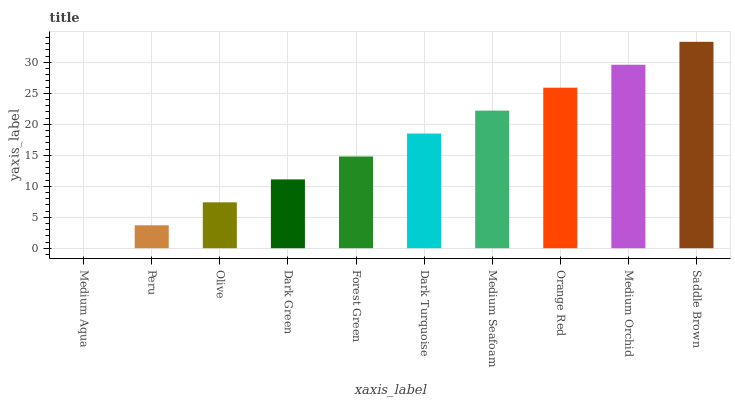Is Medium Aqua the minimum?
Answer yes or no. Yes. Is Saddle Brown the maximum?
Answer yes or no. Yes. Is Peru the minimum?
Answer yes or no. No. Is Peru the maximum?
Answer yes or no. No. Is Peru greater than Medium Aqua?
Answer yes or no. Yes. Is Medium Aqua less than Peru?
Answer yes or no. Yes. Is Medium Aqua greater than Peru?
Answer yes or no. No. Is Peru less than Medium Aqua?
Answer yes or no. No. Is Dark Turquoise the high median?
Answer yes or no. Yes. Is Forest Green the low median?
Answer yes or no. Yes. Is Forest Green the high median?
Answer yes or no. No. Is Olive the low median?
Answer yes or no. No. 